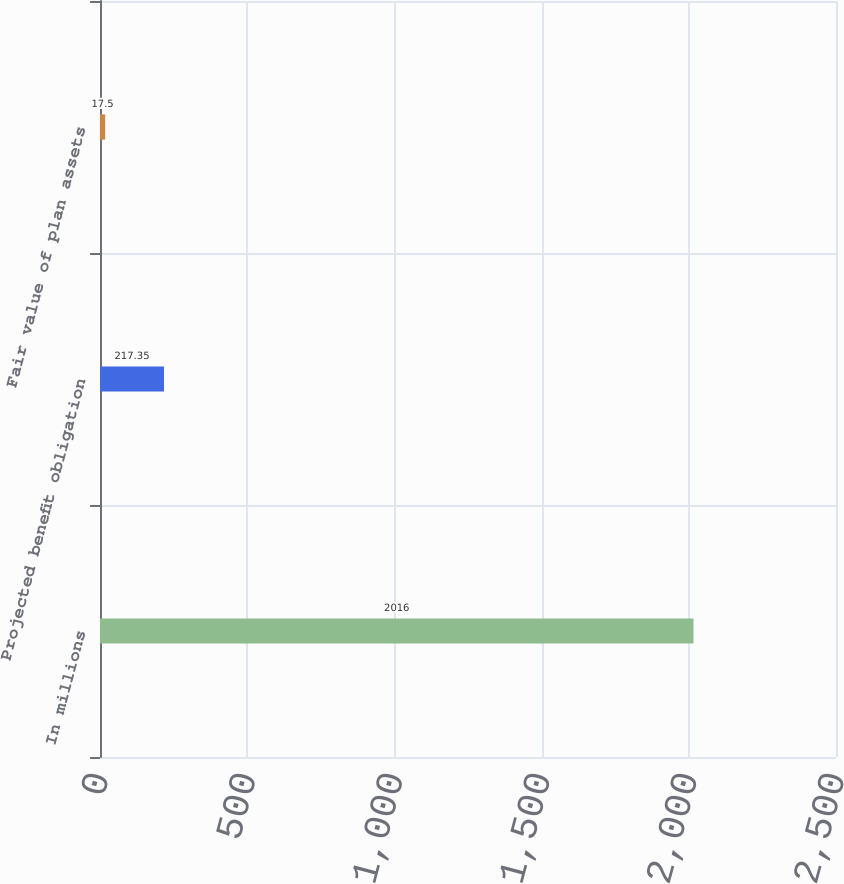Convert chart. <chart><loc_0><loc_0><loc_500><loc_500><bar_chart><fcel>In millions<fcel>Projected benefit obligation<fcel>Fair value of plan assets<nl><fcel>2016<fcel>217.35<fcel>17.5<nl></chart> 